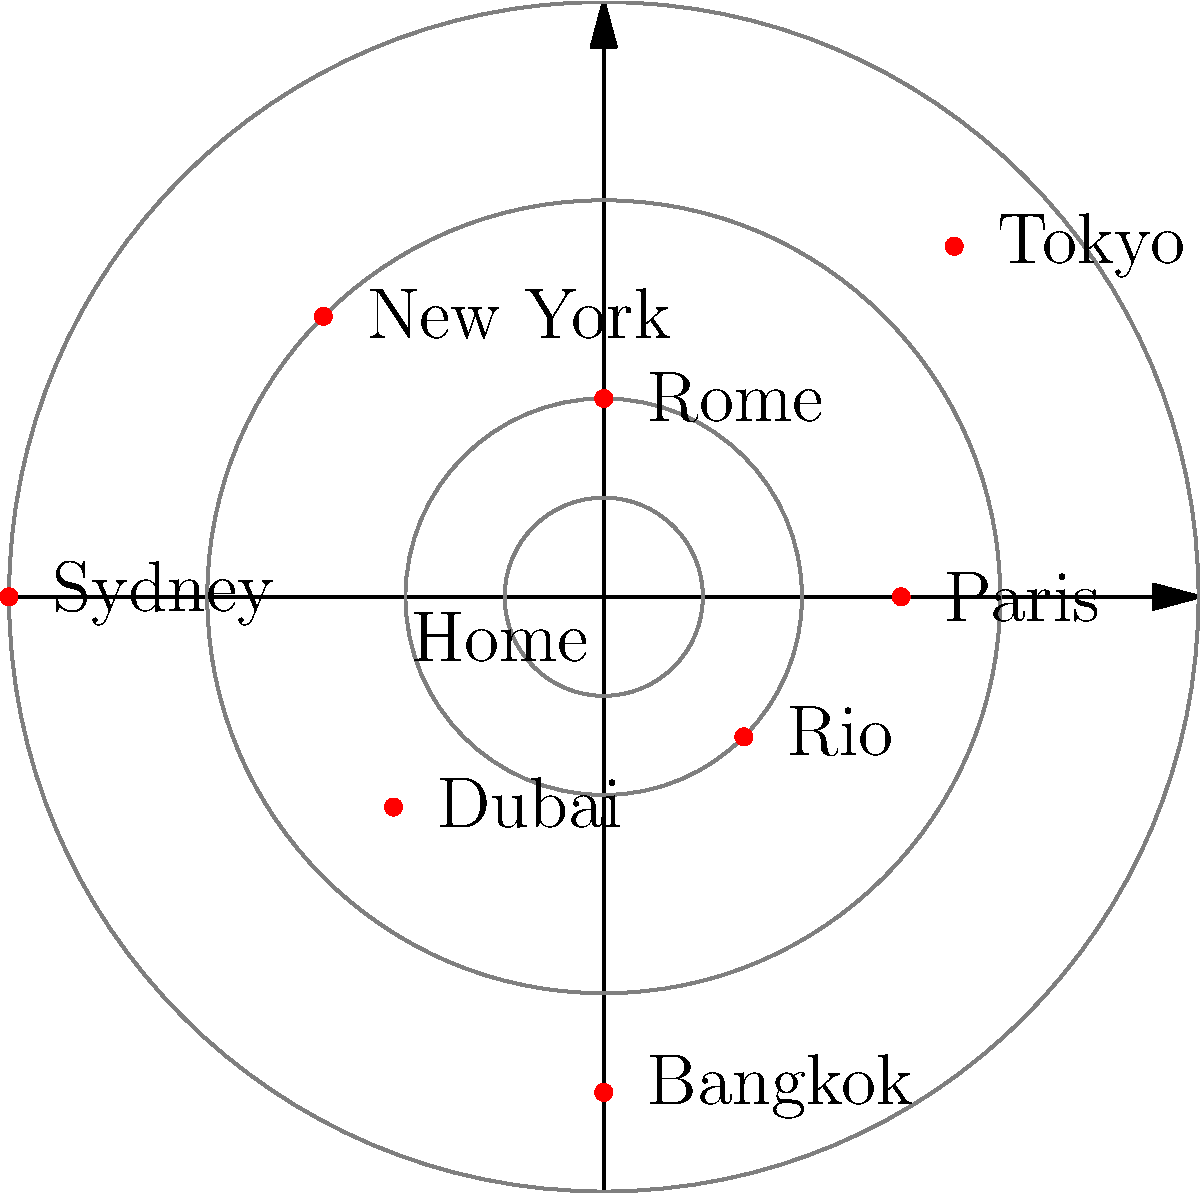Given the polar map of popular travel destinations plotted around a central "Home" point, which city is located at coordinates $(r, \theta) = (6, 180°)$? To find the city located at coordinates $(r, \theta) = (6, 180°)$, we need to follow these steps:

1. Understand the polar coordinate system:
   - $r$ represents the distance from the central point (Home)
   - $\theta$ represents the angle from the positive x-axis (counterclockwise)

2. Identify the given coordinates:
   - $r = 6$ (distance from Home)
   - $\theta = 180°$ (angle from positive x-axis)

3. Locate the point on the map:
   - A distance of 6 units from the center
   - At an angle of 180° (which is directly left of the center)

4. Examine the cities plotted on the map:
   - Paris (0°)
   - Tokyo (45°)
   - Rome (90°)
   - New York (135°)
   - Sydney (180°)
   - Dubai (225°)
   - Bangkok (270°)
   - Rio (315°)

5. Identify the city that matches the given coordinates:
   - Sydney is located at a distance of 6 units from the center
   - Sydney is at an angle of 180° from the positive x-axis

Therefore, the city located at coordinates $(r, \theta) = (6, 180°)$ is Sydney.
Answer: Sydney 